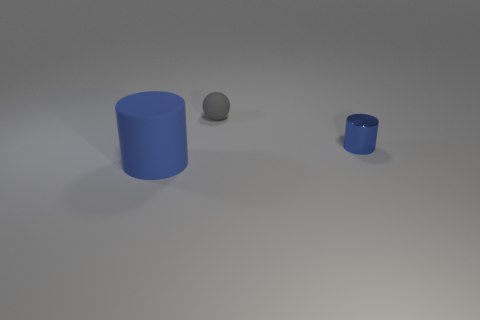Add 3 blue shiny cylinders. How many objects exist? 6 Subtract all spheres. How many objects are left? 2 Subtract all blue metallic objects. Subtract all blue rubber things. How many objects are left? 1 Add 3 gray objects. How many gray objects are left? 4 Add 1 small gray rubber objects. How many small gray rubber objects exist? 2 Subtract 0 red spheres. How many objects are left? 3 